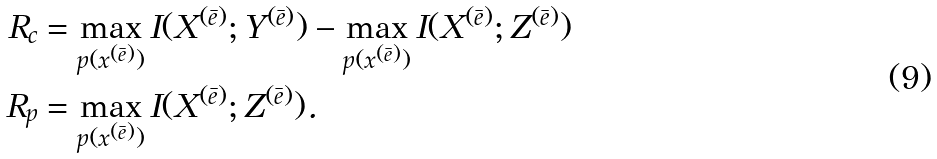<formula> <loc_0><loc_0><loc_500><loc_500>R _ { c } & = \max _ { p ( x ^ { ( \bar { e } ) } ) } I ( X ^ { ( \bar { e } ) } ; Y ^ { ( \bar { e } ) } ) - \max _ { p ( x ^ { ( \bar { e } ) } ) } I ( X ^ { ( \bar { e } ) } ; Z ^ { ( \bar { e } ) } ) \\ R _ { p } & = \max _ { p ( x ^ { ( \bar { e } ) } ) } I ( X ^ { ( \bar { e } ) } ; Z ^ { ( \bar { e } ) } ) .</formula> 